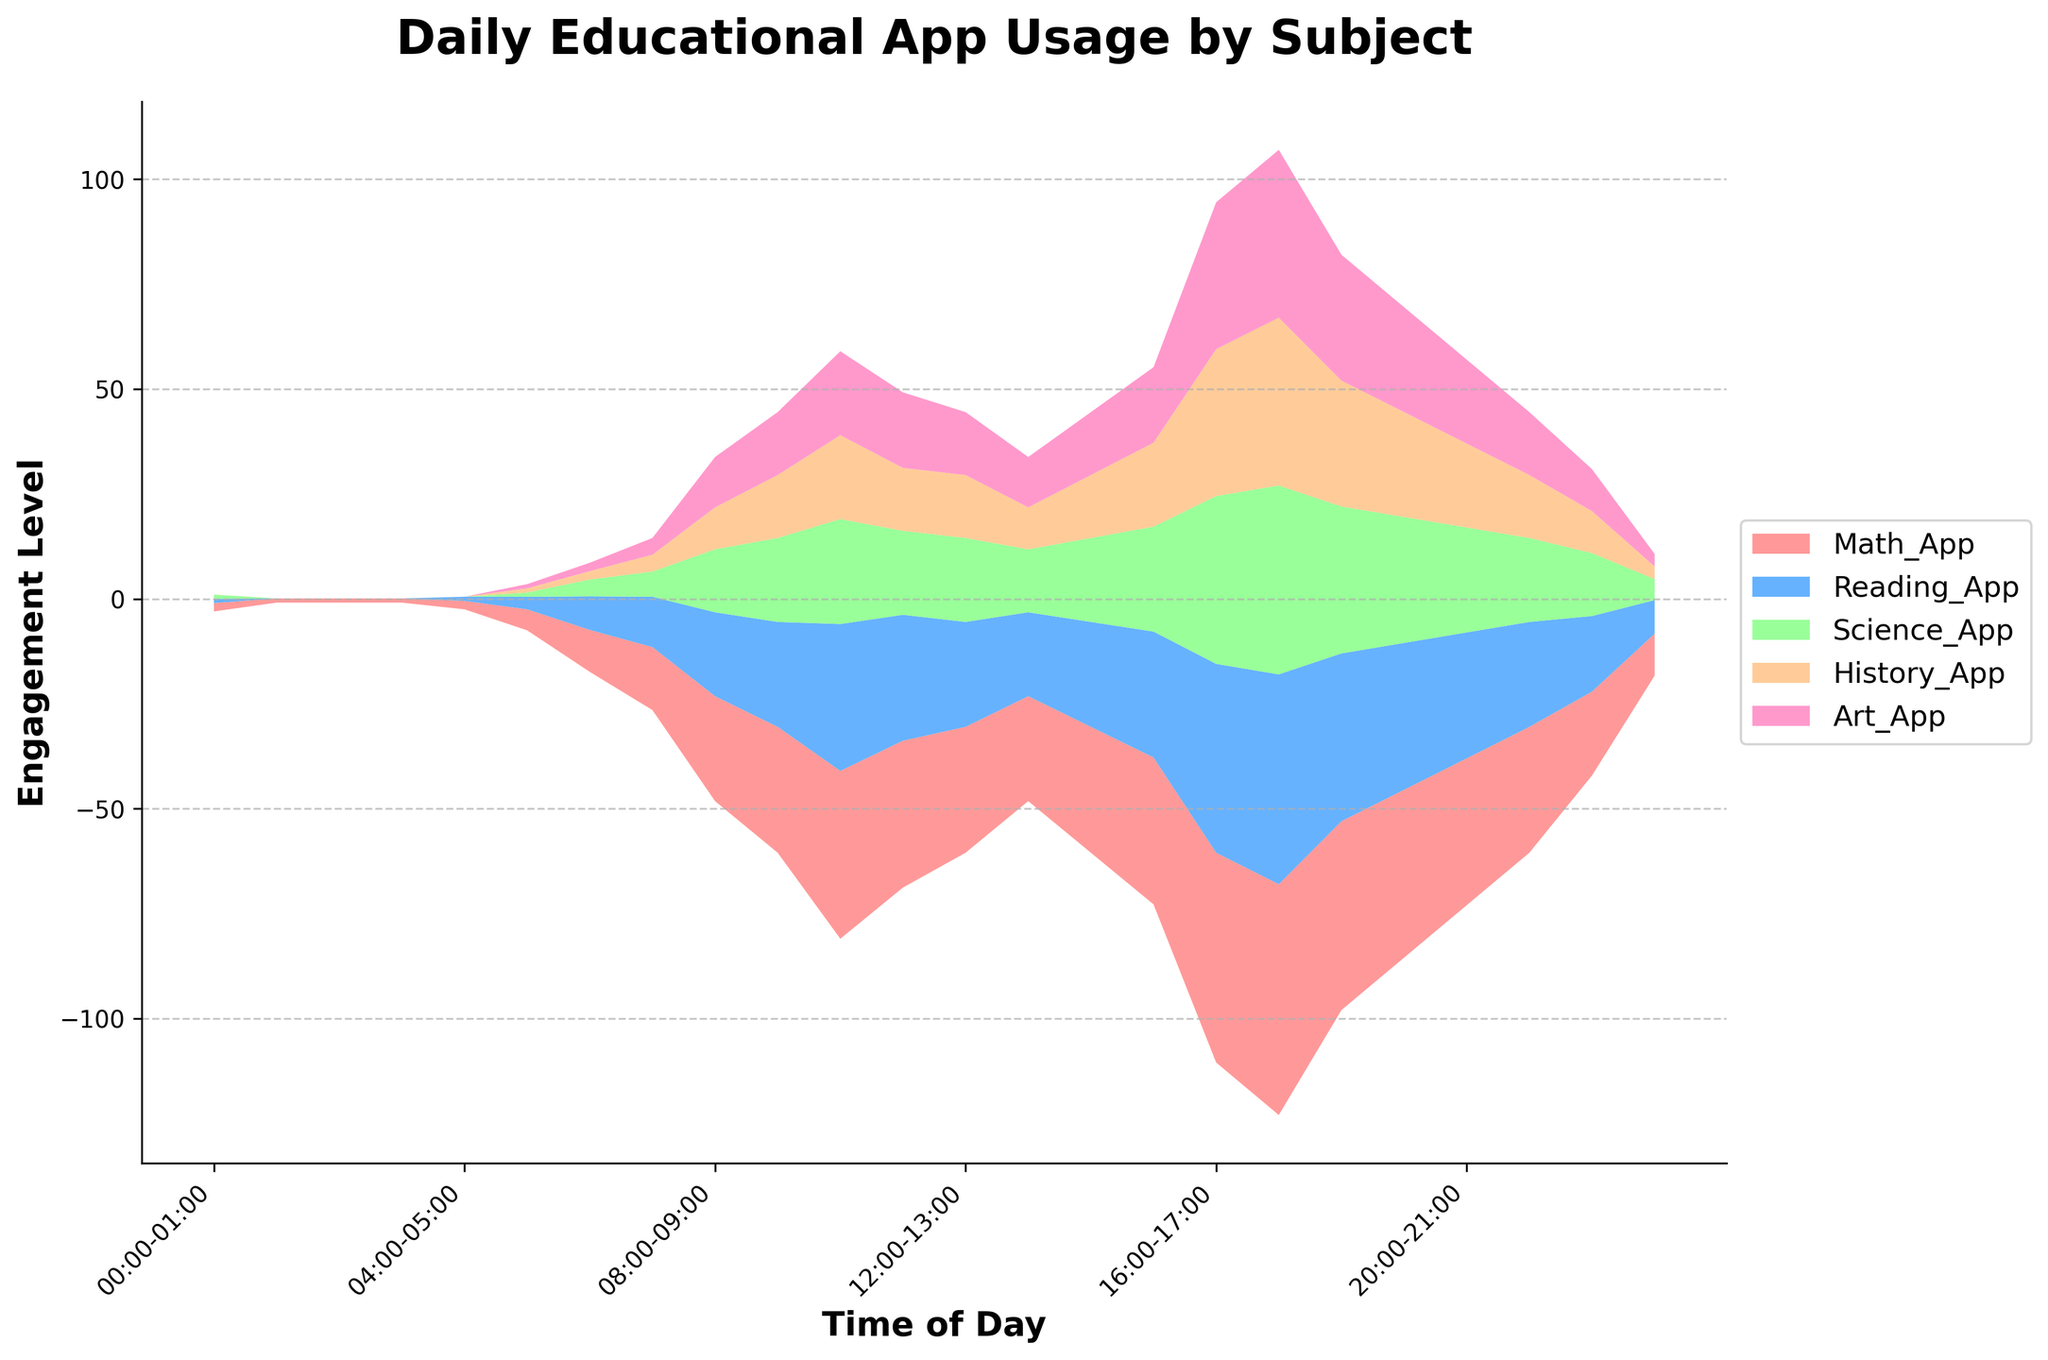What is the title of the figure? The title of the figure is typically located at the top of the graph and provides a summary description of the entire plot. In this figure, it reads "Daily Educational App Usage by Subject".
Answer: Daily Educational App Usage by Subject What are the labels on the X and Y axes? The labels on the X and Y axes are essential for understanding what each axis represents. In this figure, the X-axis is labeled "Time of Day", and the Y-axis is labeled "Engagement Level".
Answer: Time of Day, Engagement Level What are the five different colors in the stream graph representing? Each color in a stream graph represents a different category or series of data. According to the legend, the five colors represent different educational apps: Math, Reading, Science, History, and Art.
Answer: Math, Reading, Science, History, Art At what time of the day does the peak engagement level for the Math App occur? The peak engagement level for the Math App is found by locating the highest point of the Math App's color band (often the first color from the bottom) along the X-axis. From the figure, the peak appears between 17:00 and 18:00.
Answer: 17:00-18:00 During which time period is the engagement level for educational content the lowest? To identify the lowest engagement period, we look for the smallest combined width of all layers on the Y-axis. This is seen in the early hours between 01:00 and 02:00.
Answer: 01:00-02:00 How many hours of the day does the engagement level for the Art App stay above 20? This requires visually inspecting the width of the Art App's color band (often the top layer) and counting the hours it remains consistently above the 20 engagement level mark on the Y-axis. It stays above 20 between 16:00 and 19:00, totaling 3 hours.
Answer: 3 hours Which app shows a significant increase in engagement between 15:00 and 16:00? To determine significant increases, observe the change in width of each colored band. During this time period, the Math App (usually the first layer) shows a notable increase in width.
Answer: Math App Between 14:00 and 15:00, which two apps have similar engagement levels? This involves comparing the widths of the color bands visually for the given time period. Between 14:00 and 15:00, the Science App and History App (third and fourth layers) have similar engagement levels.
Answer: Science App, History App What is the trend of engagement levels for the Reading App throughout the day? By following the band color of the Reading App across the X-axis, we see a gradual increase in the morning, reaching a peak by early afternoon around 17:00-18:00, then slowly declining into the night.
Answer: Increases, peaks, and then decreases Which time of the day shows the most balanced usage across all educational apps? Balanced usage implies all colors have similar widths. Around 15:00-16:00, no single app dominates the chart, indicating balanced usage among Math, Reading, Science, History, and Art.
Answer: 15:00-16:00 